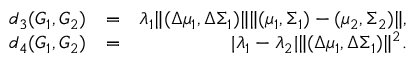Convert formula to latex. <formula><loc_0><loc_0><loc_500><loc_500>\begin{array} { r l r } { d _ { 3 } ( G _ { 1 } , G _ { 2 } ) } & { = } & { \lambda _ { 1 } \| ( \Delta \mu _ { 1 } , \Delta \Sigma _ { 1 } ) \| \| ( \mu _ { 1 } , \Sigma _ { 1 } ) - ( \mu _ { 2 } , \Sigma _ { 2 } ) \| , } \\ { d _ { 4 } ( G _ { 1 } , G _ { 2 } ) } & { = } & { | \lambda _ { 1 } - \lambda _ { 2 } | \| ( \Delta \mu _ { 1 } , \Delta \Sigma _ { 1 } ) \| ^ { 2 } . } \end{array}</formula> 